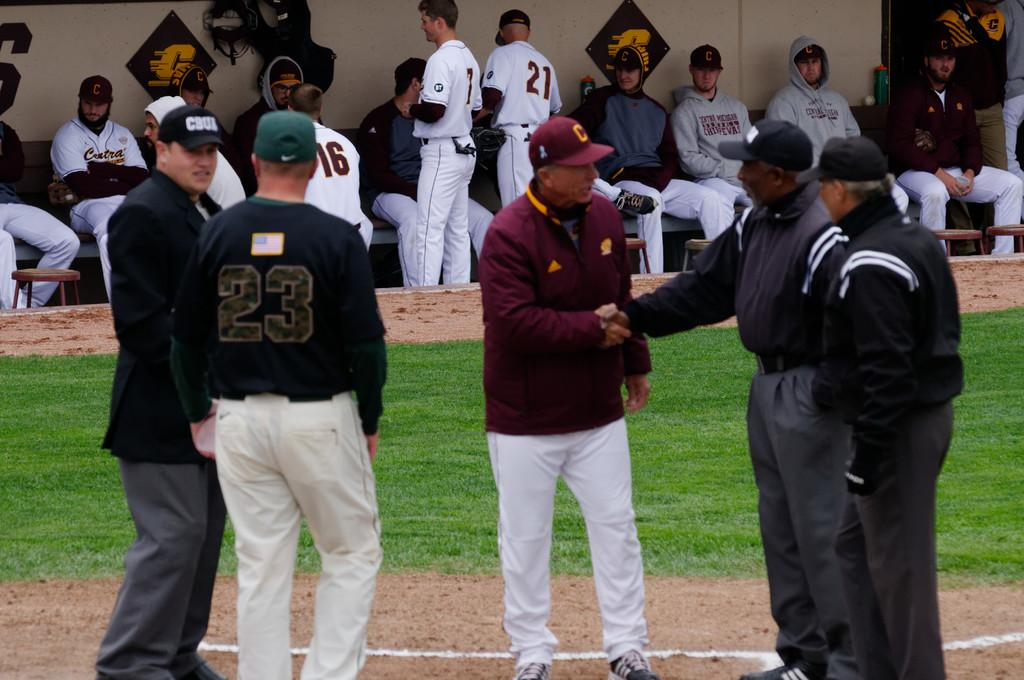Provide a one-sentence caption for the provided image. As officials confer on the mound, players wearing 21, 16 and other numbers converse in the dugout. 